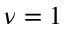<formula> <loc_0><loc_0><loc_500><loc_500>\nu = 1</formula> 